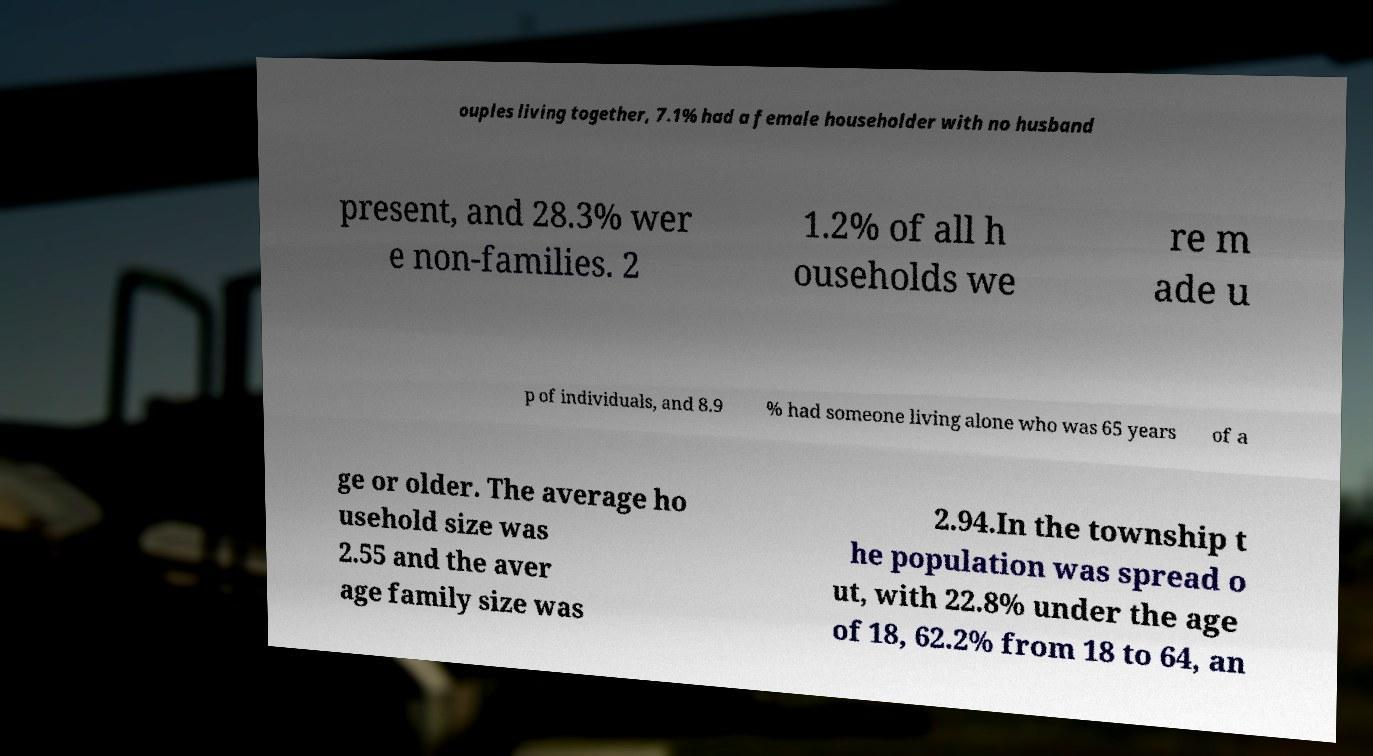Could you extract and type out the text from this image? ouples living together, 7.1% had a female householder with no husband present, and 28.3% wer e non-families. 2 1.2% of all h ouseholds we re m ade u p of individuals, and 8.9 % had someone living alone who was 65 years of a ge or older. The average ho usehold size was 2.55 and the aver age family size was 2.94.In the township t he population was spread o ut, with 22.8% under the age of 18, 62.2% from 18 to 64, an 